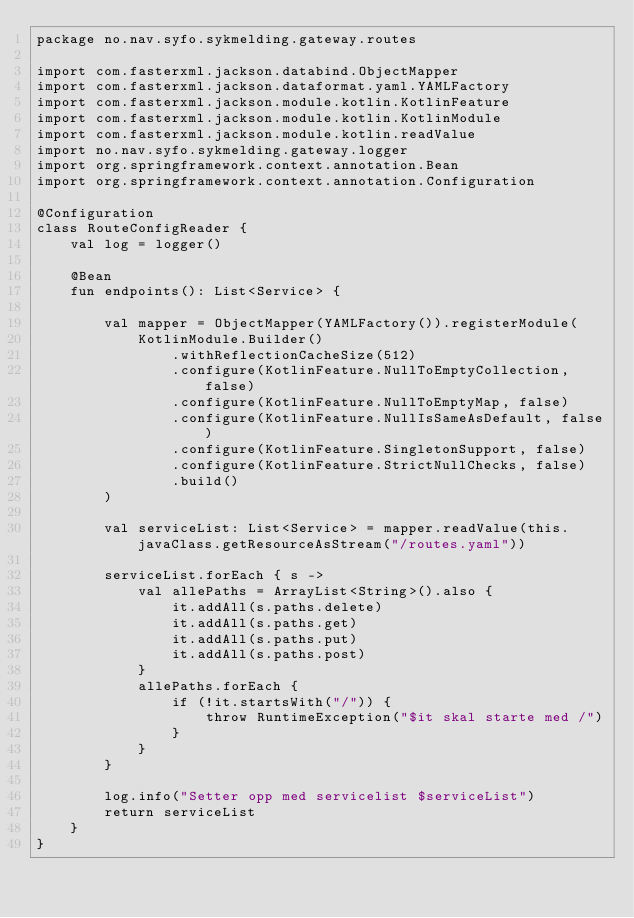<code> <loc_0><loc_0><loc_500><loc_500><_Kotlin_>package no.nav.syfo.sykmelding.gateway.routes

import com.fasterxml.jackson.databind.ObjectMapper
import com.fasterxml.jackson.dataformat.yaml.YAMLFactory
import com.fasterxml.jackson.module.kotlin.KotlinFeature
import com.fasterxml.jackson.module.kotlin.KotlinModule
import com.fasterxml.jackson.module.kotlin.readValue
import no.nav.syfo.sykmelding.gateway.logger
import org.springframework.context.annotation.Bean
import org.springframework.context.annotation.Configuration

@Configuration
class RouteConfigReader {
    val log = logger()

    @Bean
    fun endpoints(): List<Service> {

        val mapper = ObjectMapper(YAMLFactory()).registerModule(
            KotlinModule.Builder()
                .withReflectionCacheSize(512)
                .configure(KotlinFeature.NullToEmptyCollection, false)
                .configure(KotlinFeature.NullToEmptyMap, false)
                .configure(KotlinFeature.NullIsSameAsDefault, false)
                .configure(KotlinFeature.SingletonSupport, false)
                .configure(KotlinFeature.StrictNullChecks, false)
                .build()
        )

        val serviceList: List<Service> = mapper.readValue(this.javaClass.getResourceAsStream("/routes.yaml"))

        serviceList.forEach { s ->
            val allePaths = ArrayList<String>().also {
                it.addAll(s.paths.delete)
                it.addAll(s.paths.get)
                it.addAll(s.paths.put)
                it.addAll(s.paths.post)
            }
            allePaths.forEach {
                if (!it.startsWith("/")) {
                    throw RuntimeException("$it skal starte med /")
                }
            }
        }

        log.info("Setter opp med servicelist $serviceList")
        return serviceList
    }
}
</code> 